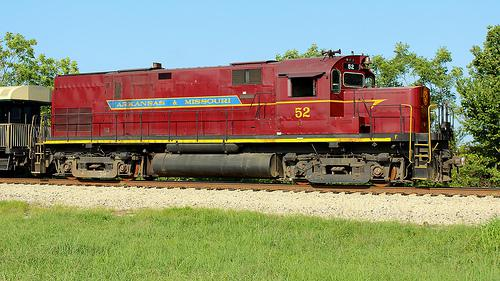Question: when was this picture taken?
Choices:
A. Last night.
B. Daytime.
C. Two days ago.
D. Five minutes ago.
Answer with the letter. Answer: B Question: where was this picture taken?
Choices:
A. In a school.
B. Railway.
C. Outside the library.
D. In my house.
Answer with the letter. Answer: B Question: what color are the train numbers?
Choices:
A. White.
B. Yellow.
C. Black.
D. Orange.
Answer with the letter. Answer: B Question: what number is the train?
Choices:
A. 33.
B. 52.
C. 42.
D. 7.
Answer with the letter. Answer: B Question: how is the weather?
Choices:
A. Rainy.
B. Cold.
C. Sunny.
D. Windy.
Answer with the letter. Answer: C 